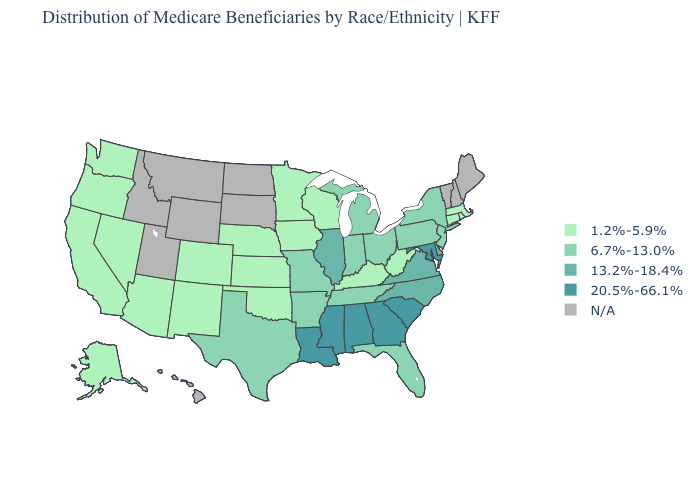How many symbols are there in the legend?
Keep it brief. 5. What is the highest value in the USA?
Short answer required. 20.5%-66.1%. Name the states that have a value in the range 20.5%-66.1%?
Keep it brief. Alabama, Georgia, Louisiana, Maryland, Mississippi, South Carolina. Does the first symbol in the legend represent the smallest category?
Keep it brief. Yes. What is the value of New Hampshire?
Give a very brief answer. N/A. What is the value of Florida?
Concise answer only. 6.7%-13.0%. Does the first symbol in the legend represent the smallest category?
Write a very short answer. Yes. What is the value of Colorado?
Write a very short answer. 1.2%-5.9%. What is the lowest value in the USA?
Give a very brief answer. 1.2%-5.9%. Does Massachusetts have the lowest value in the Northeast?
Answer briefly. Yes. What is the lowest value in states that border Iowa?
Be succinct. 1.2%-5.9%. Among the states that border Kentucky , which have the highest value?
Short answer required. Illinois, Virginia. 